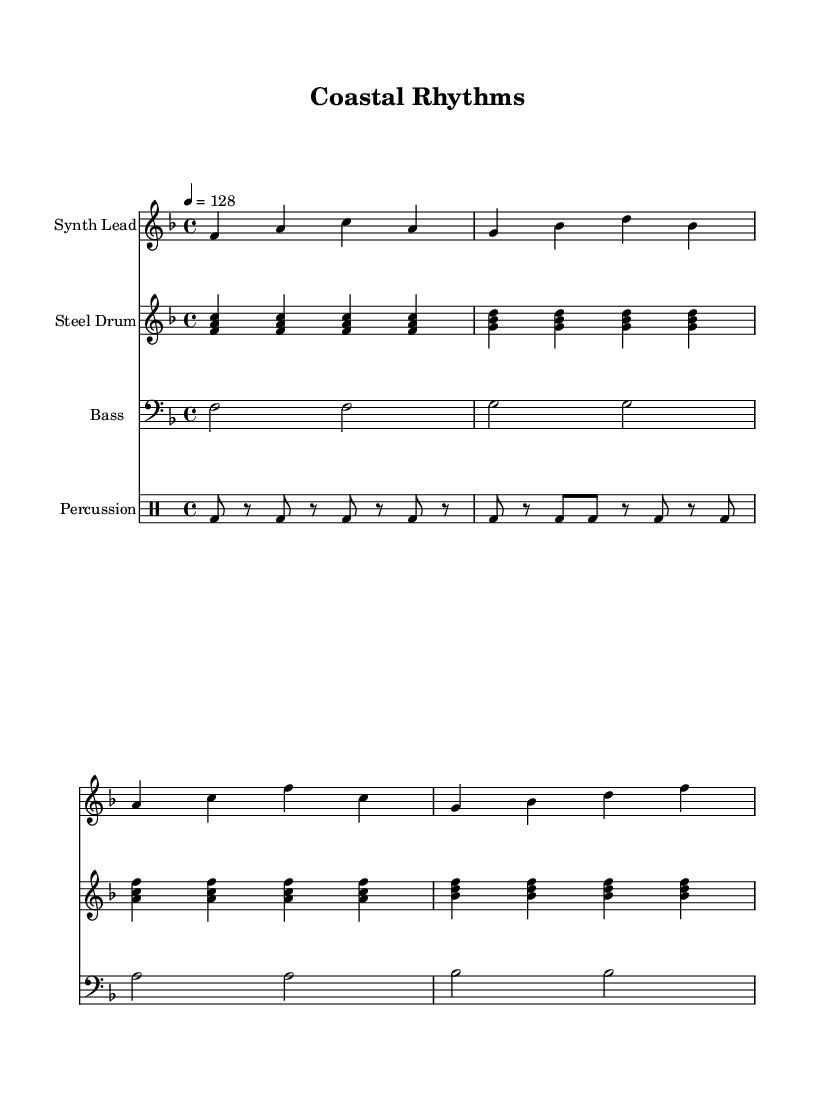What is the key signature of this music? The key signature appears as F major, represented by one flat (B flat) on the staff.
Answer: F major What is the time signature of this music? The time signature is clearly marked at the beginning with a "4/4," indicating four beats per measure.
Answer: 4/4 What is the tempo marking of this piece? The tempo marking shows "4 = 128," indicating that the quarter note gets 128 beats per minute.
Answer: 128 What instrument plays the synth lead? The instrument labeled at the beginning of its staff is "Synth Lead," indicating it plays the synth melody.
Answer: Synth Lead How many measures are in the synth lead part? By counting the measures in the synth lead notation, there are four measures indicated by the bar lines.
Answer: 4 What type of percussion is used in this score? The percussion part is specified as "bd," which stands for bass drum, indicating the type of percussion used.
Answer: Bass drum What is the range of the bass line? The bass line consists of notes that range from F to B flat, confirming the notes played throughout the measures.
Answer: F to B flat 